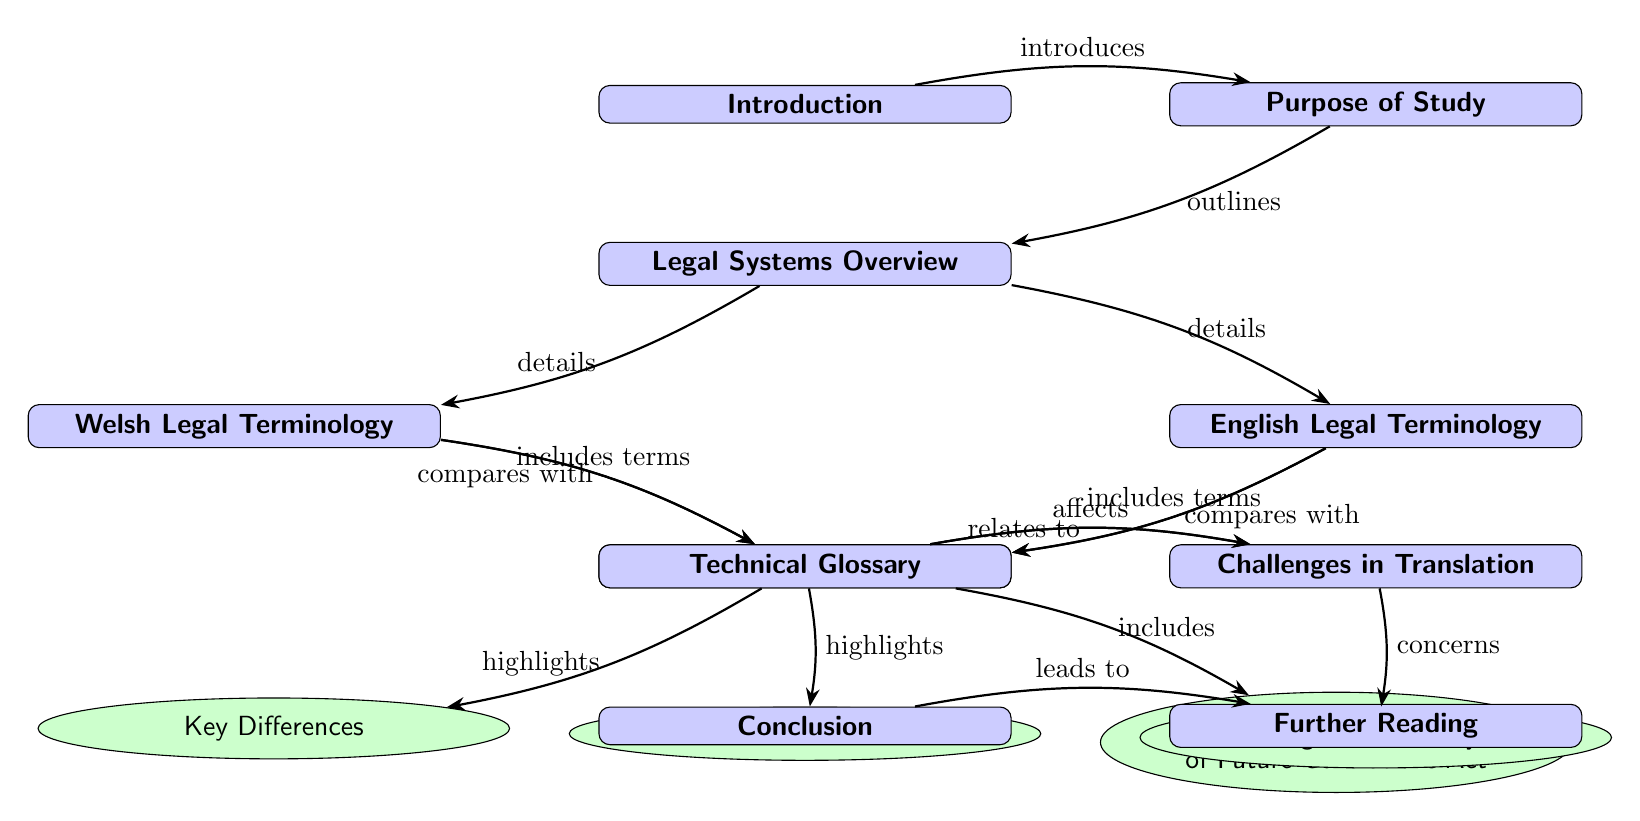What is the first node in the diagram? The first node in the diagram is "Introduction," which is placed at the top as the initial section of the flow.
Answer: Introduction How many subsections are there under "Comparative Analysis"? There are three subsections under "Comparative Analysis": "Key Differences," "Cultural Context," and "Case Study: Well-being of Future Generations Act."
Answer: 3 Which node is directly to the right of "Comparative Analysis"? The node directly to the right of "Comparative Analysis" is "Challenges in Translation," which is positioned to the right side of the comparative section.
Answer: Challenges in Translation What does "Comparative Analysis" highlight? "Comparative Analysis" highlights "Key Differences," "Cultural Context," and includes "Case Study: Well-being of Future Generations Act," showing it emphasizes multiple aspects connected to the analysis.
Answer: Key Differences, Cultural Context, Case Study: Well-being of Future Generations Act What relationship does the "Overview" node have with the "Welsh Legal Terminology" and "English Legal Terminology" nodes? The "Overview" node details both "Welsh Legal Terminology" and "English Legal Terminology," indicating it provides foundational information about each legal system.
Answer: details What is the connection between "Glossary" and "Challenges in Translation"? The "Glossary" relates to "Challenges in Translation," pointing out that the technical terms defined in the glossary directly influence the challenges encountered in translating legal language.
Answer: relates to Which section comes after "Purpose of Study"? The section that comes after "Purpose of Study" is "Legal Systems Overview", which is positioned directly below it in the flow of the diagram.
Answer: Legal Systems Overview What is included in the "Glossary" node? The "Glossary" node includes terms from both "Welsh Legal Terminology" and "English Legal Terminology," as it gathers the specific legal terms pertinent to both languages in this context.
Answer: includes terms What leads to "Further Reading"? The conclusion leads to "Further Reading," indicating that upon summarizing the findings, additional resources or literature are suggested for further exploration of the topic.
Answer: leads to 